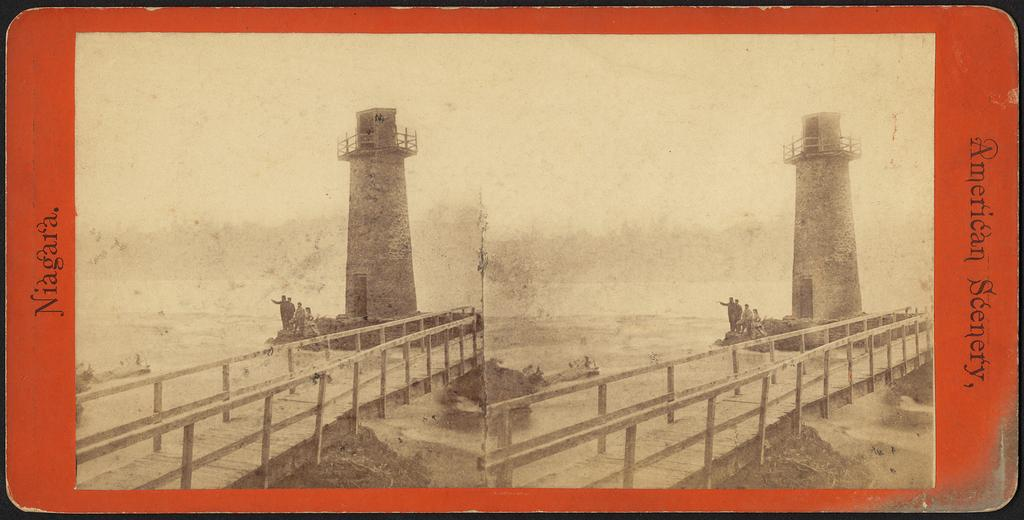<image>
Write a terse but informative summary of the picture. a light house with the word American on the right 